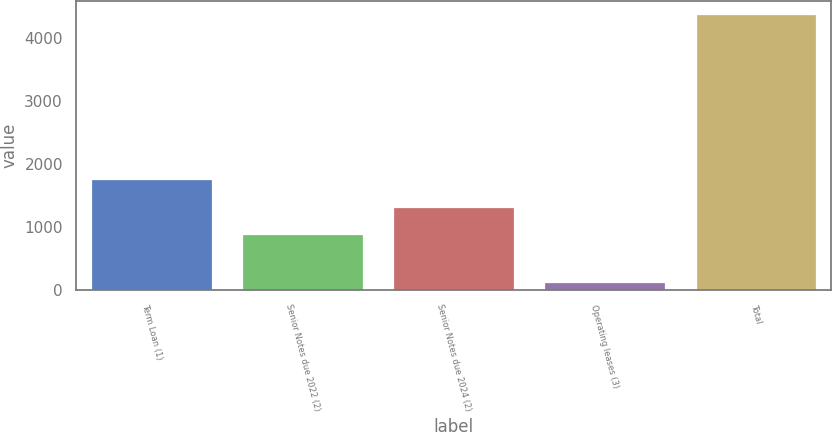<chart> <loc_0><loc_0><loc_500><loc_500><bar_chart><fcel>Term Loan (1)<fcel>Senior Notes due 2022 (2)<fcel>Senior Notes due 2024 (2)<fcel>Operating leases (3)<fcel>Total<nl><fcel>1767.8<fcel>889<fcel>1313.52<fcel>127.5<fcel>4372.7<nl></chart> 